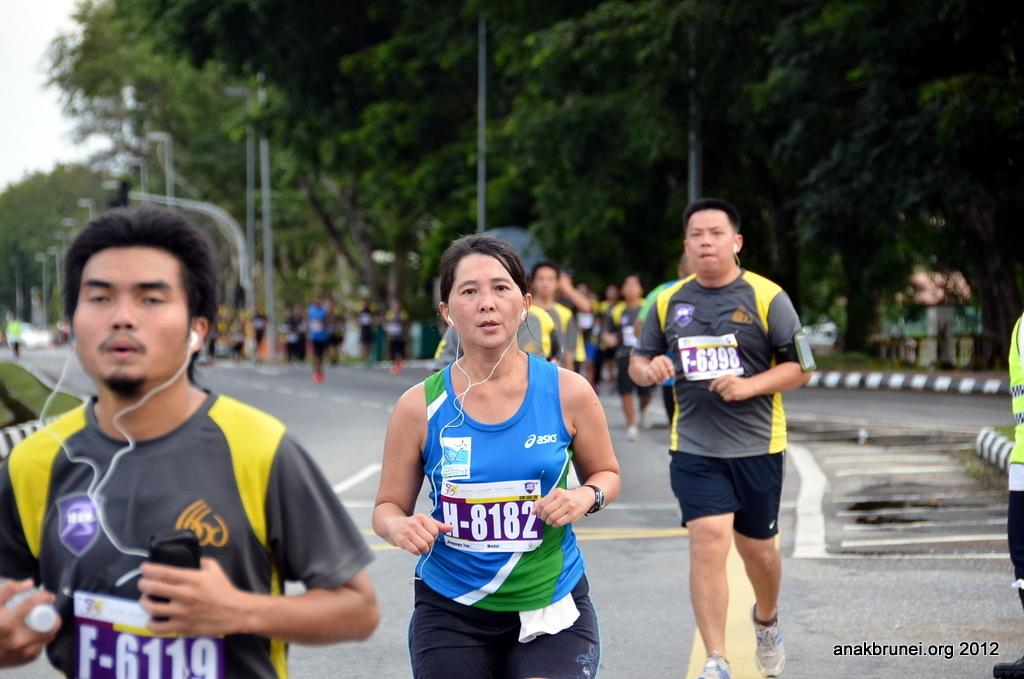How many people are in the image? There is a group of persons in the image. What are the persons in the image doing? The persons are running. What can be seen in the background of the image? There are trees and poles in the background of the image. What type of vegetation is on the ground on the left side of the image? There is grass on the ground on the left side of the image. What type of quill is being used by the scarecrow in the image? There is no scarecrow or quill present in the image. What material is the floor made of in the image? There is no floor present in the image; it is an outdoor scene with grass on the ground. 